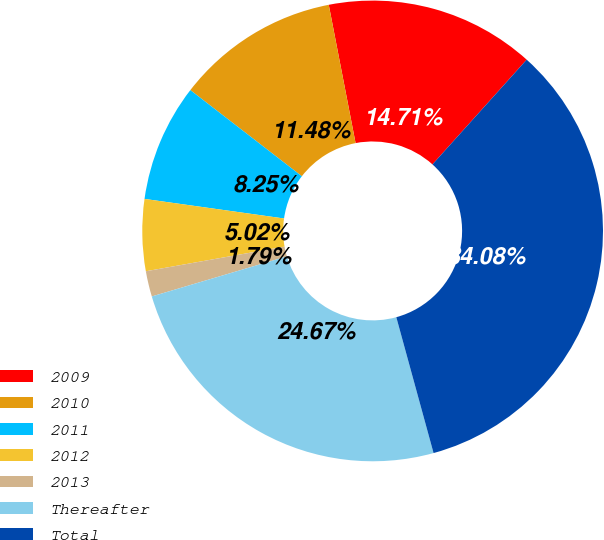Convert chart. <chart><loc_0><loc_0><loc_500><loc_500><pie_chart><fcel>2009<fcel>2010<fcel>2011<fcel>2012<fcel>2013<fcel>Thereafter<fcel>Total<nl><fcel>14.71%<fcel>11.48%<fcel>8.25%<fcel>5.02%<fcel>1.79%<fcel>24.67%<fcel>34.08%<nl></chart> 